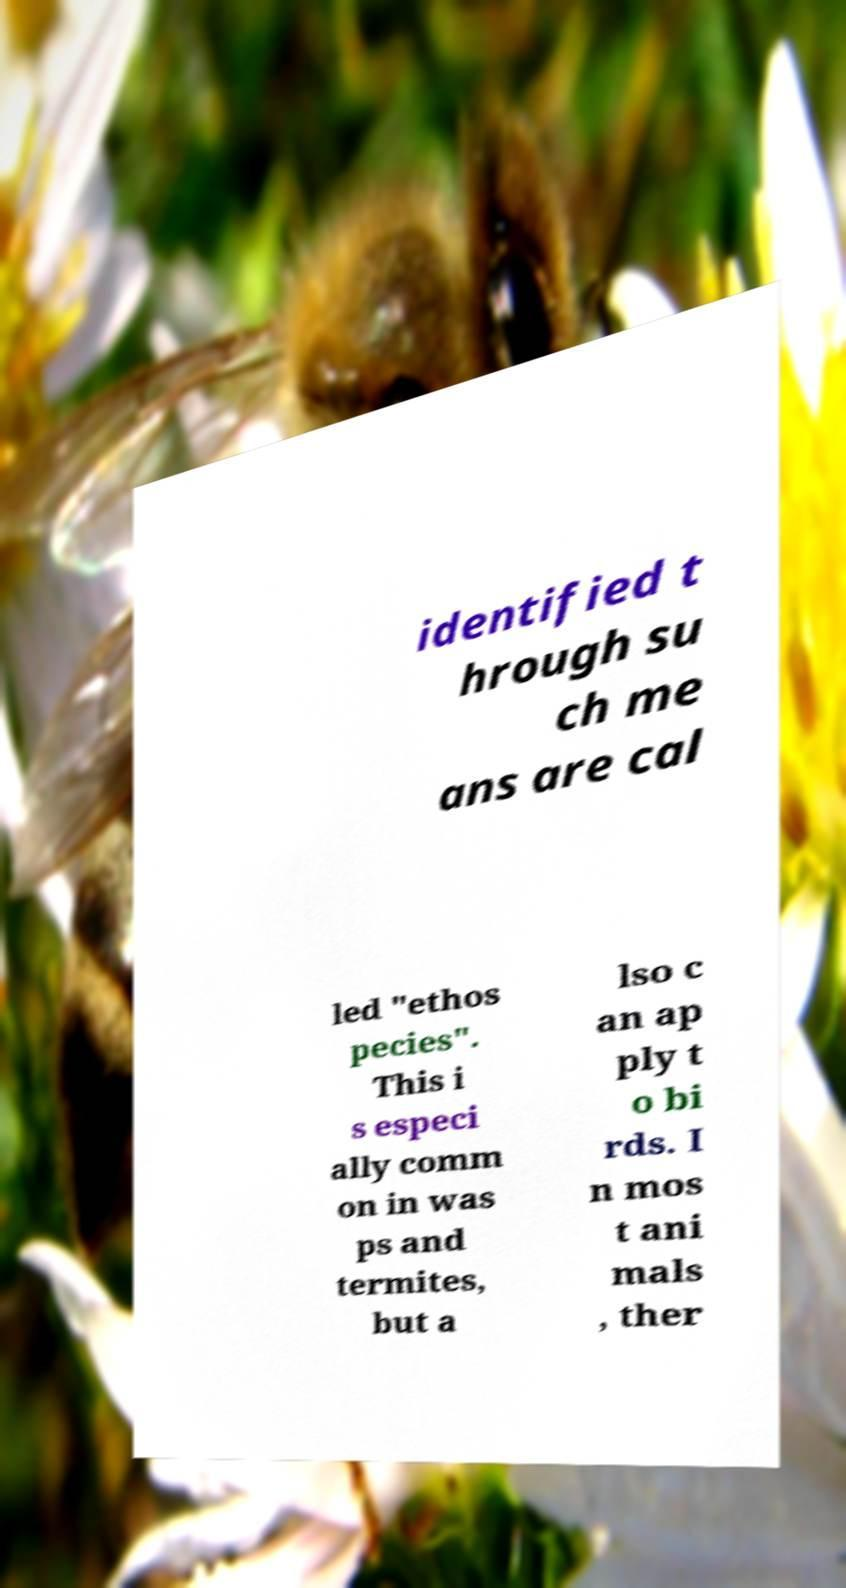For documentation purposes, I need the text within this image transcribed. Could you provide that? identified t hrough su ch me ans are cal led "ethos pecies". This i s especi ally comm on in was ps and termites, but a lso c an ap ply t o bi rds. I n mos t ani mals , ther 